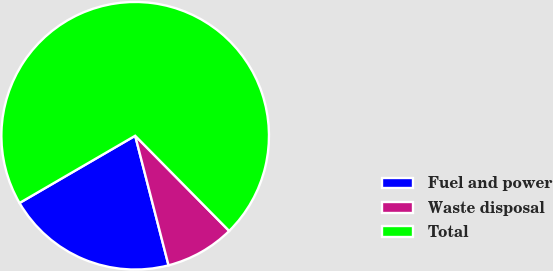<chart> <loc_0><loc_0><loc_500><loc_500><pie_chart><fcel>Fuel and power<fcel>Waste disposal<fcel>Total<nl><fcel>20.63%<fcel>8.39%<fcel>70.98%<nl></chart> 